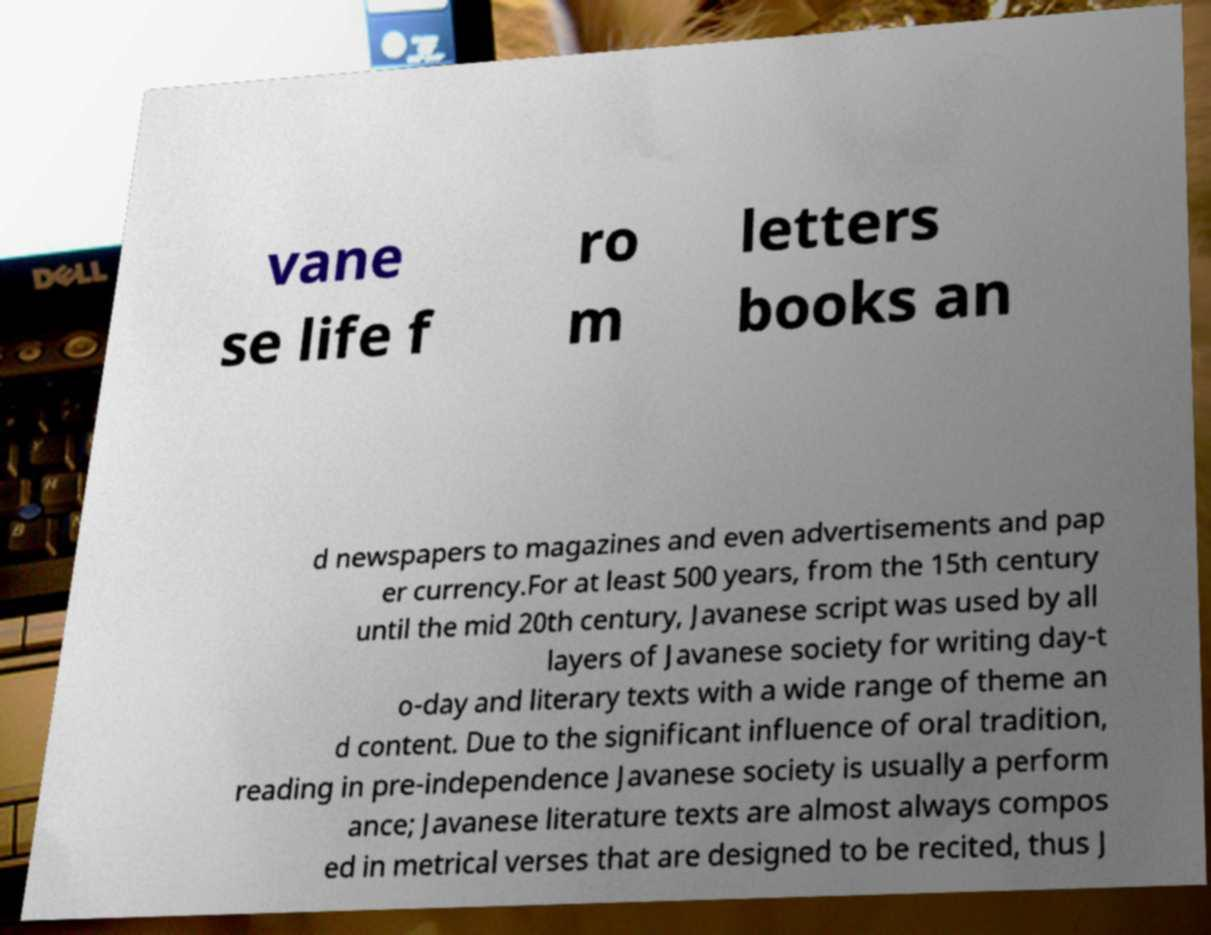There's text embedded in this image that I need extracted. Can you transcribe it verbatim? vane se life f ro m letters books an d newspapers to magazines and even advertisements and pap er currency.For at least 500 years, from the 15th century until the mid 20th century, Javanese script was used by all layers of Javanese society for writing day-t o-day and literary texts with a wide range of theme an d content. Due to the significant influence of oral tradition, reading in pre-independence Javanese society is usually a perform ance; Javanese literature texts are almost always compos ed in metrical verses that are designed to be recited, thus J 